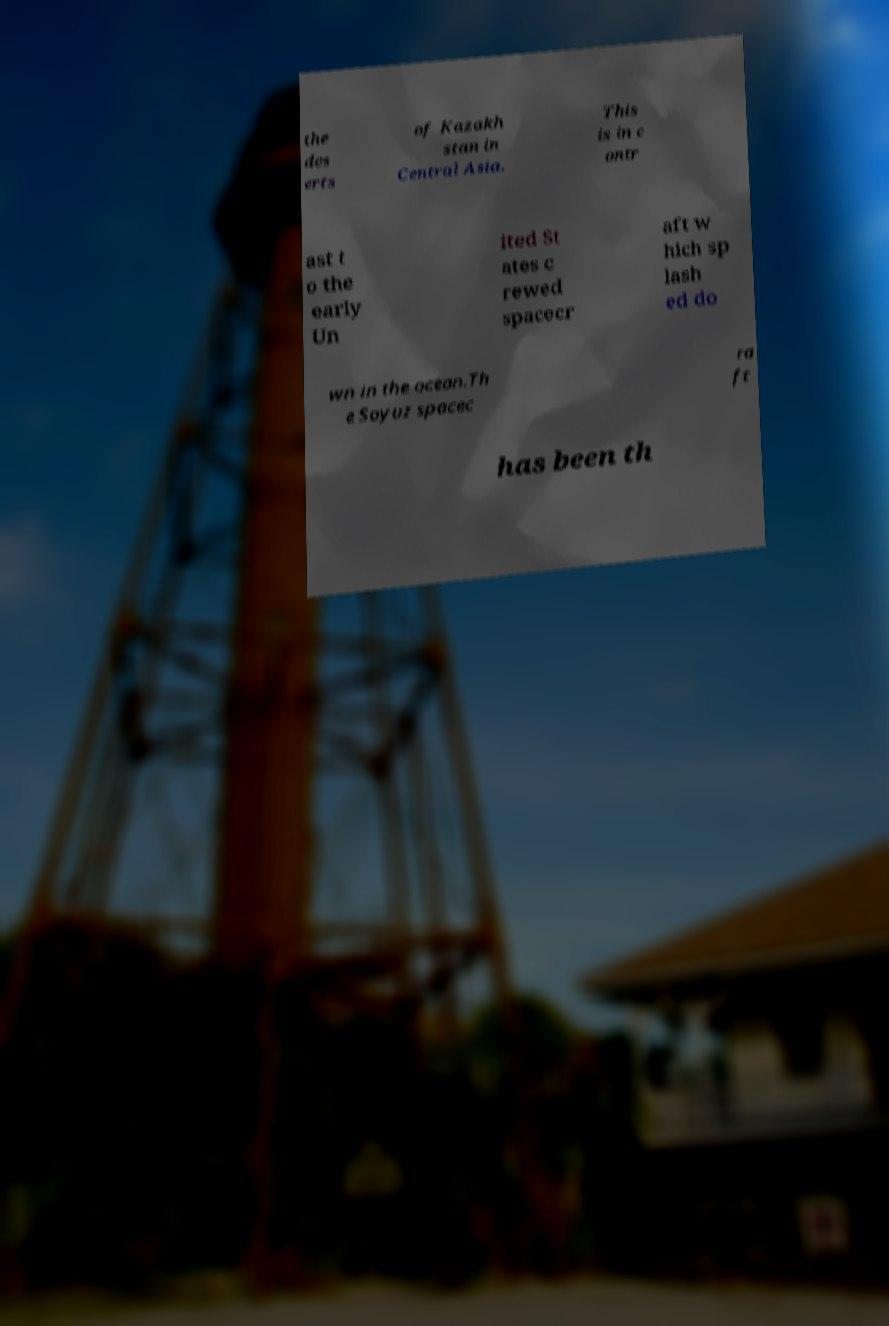For documentation purposes, I need the text within this image transcribed. Could you provide that? the des erts of Kazakh stan in Central Asia. This is in c ontr ast t o the early Un ited St ates c rewed spacecr aft w hich sp lash ed do wn in the ocean.Th e Soyuz spacec ra ft has been th 